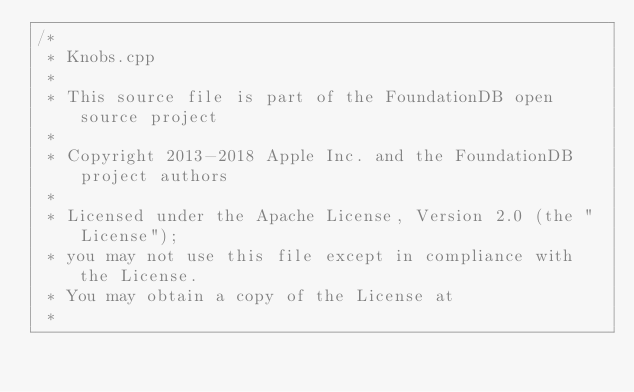<code> <loc_0><loc_0><loc_500><loc_500><_C++_>/*
 * Knobs.cpp
 *
 * This source file is part of the FoundationDB open source project
 *
 * Copyright 2013-2018 Apple Inc. and the FoundationDB project authors
 *
 * Licensed under the Apache License, Version 2.0 (the "License");
 * you may not use this file except in compliance with the License.
 * You may obtain a copy of the License at
 *</code> 